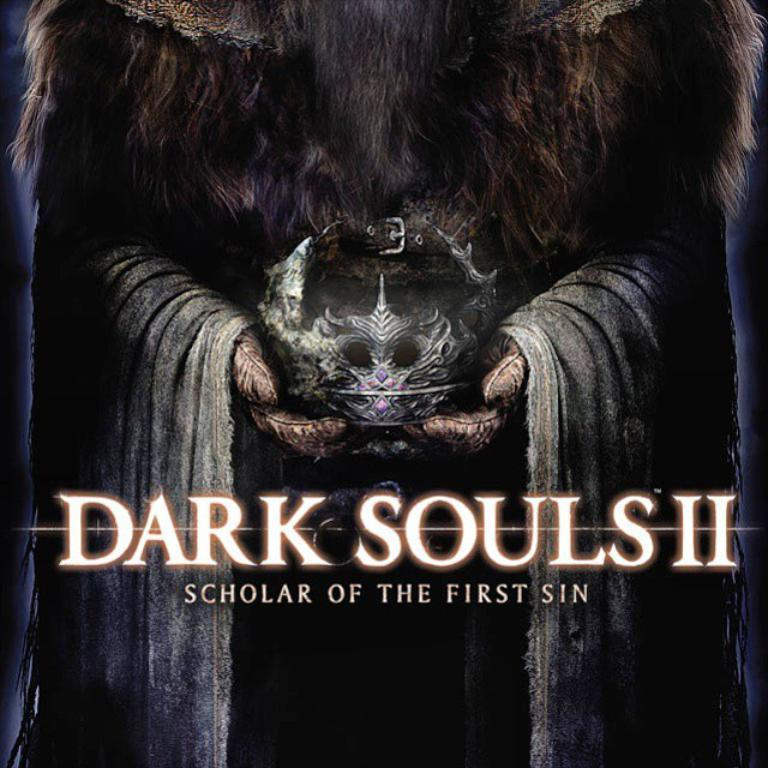What is featured in the image? There is a poster in the image. What is the person holding in the image? The person is holding a crown in the image. What else can be seen in the image besides the poster and the person holding the crown? There is text in the image. Where are the cherries placed in the image? There are no cherries present in the image. What type of jewel is the person wearing in the image? There is no jewel visible on the person in the image. 